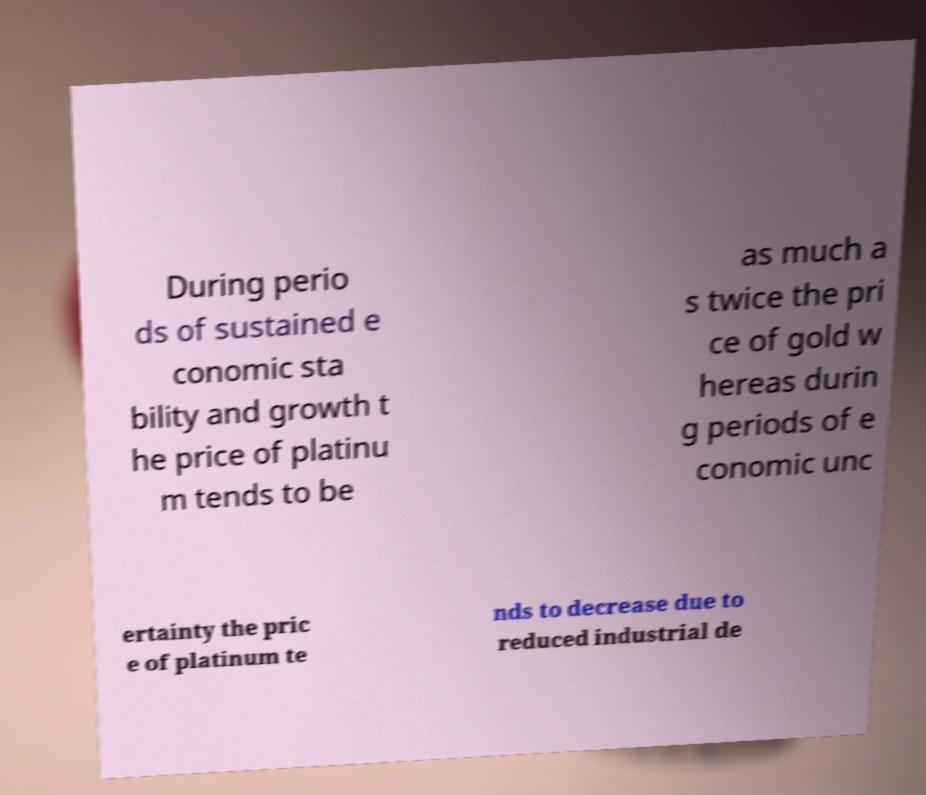Please identify and transcribe the text found in this image. During perio ds of sustained e conomic sta bility and growth t he price of platinu m tends to be as much a s twice the pri ce of gold w hereas durin g periods of e conomic unc ertainty the pric e of platinum te nds to decrease due to reduced industrial de 